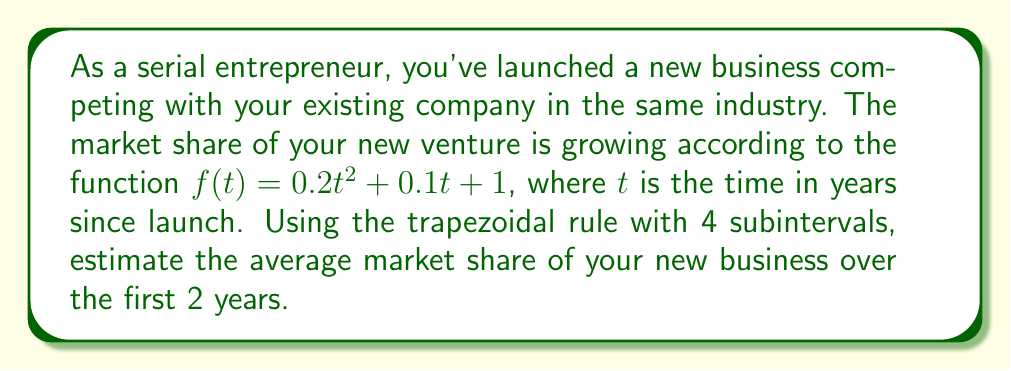Can you solve this math problem? 1) The trapezoidal rule for numerical integration is given by:

   $$\int_{a}^{b} f(x) dx \approx \frac{h}{2}\left[f(x_0) + 2f(x_1) + 2f(x_2) + ... + 2f(x_{n-1}) + f(x_n)\right]$$

   where $h = \frac{b-a}{n}$, and $n$ is the number of subintervals.

2) In this case, $a=0$, $b=2$, and $n=4$. So, $h = \frac{2-0}{4} = 0.5$

3) We need to evaluate $f(t)$ at $t = 0, 0.5, 1, 1.5,$ and $2$:

   $f(0) = 0.2(0)^2 + 0.1(0) + 1 = 1$
   $f(0.5) = 0.2(0.5)^2 + 0.1(0.5) + 1 = 1.075$
   $f(1) = 0.2(1)^2 + 0.1(1) + 1 = 1.3$
   $f(1.5) = 0.2(1.5)^2 + 0.1(1.5) + 1 = 1.675$
   $f(2) = 0.2(2)^2 + 0.1(2) + 1 = 2.2$

4) Applying the trapezoidal rule:

   $$\int_{0}^{2} f(t) dt \approx \frac{0.5}{2}[1 + 2(1.075) + 2(1.3) + 2(1.675) + 2.2]$$
   $$= 0.25[1 + 2.15 + 2.6 + 3.35 + 2.2]$$
   $$= 0.25[11.3] = 2.825$$

5) To find the average, divide by the interval length:

   Average market share $= \frac{2.825}{2} = 1.4125$
Answer: 1.4125 